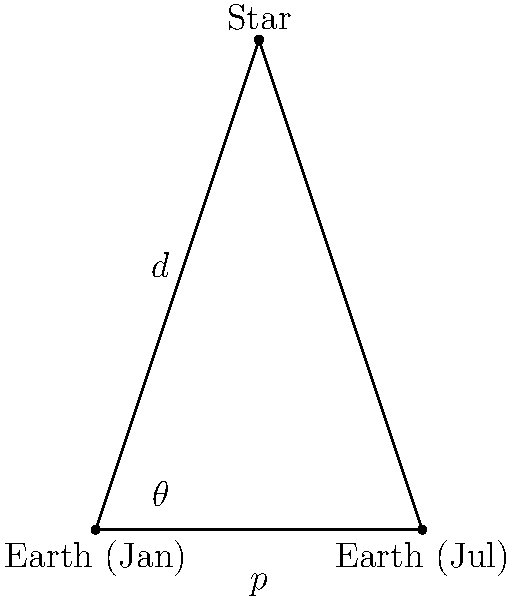As a 911 technology developer, you understand the importance of precise location data. In astronomy, determining the distance to stars is crucial. If a star has a parallax angle of 0.5 arcseconds when observed from Earth at opposite points in its orbit, what is the distance to this star in light-years? (Assume Earth's orbit radius is 1 AU) To calculate the distance to the star, we'll use the parallax method:

1) First, convert the parallax angle from arcseconds to radians:
   $\theta = 0.5 \text{ arcseconds} = 0.5 \times \frac{\pi}{180 \times 3600} \approx 2.4242 \times 10^{-6} \text{ radians}$

2) The distance $d$ to the star is given by the formula:
   $d = \frac{1 \text{ AU}}{\tan(\theta)}$

3) For small angles, $\tan(\theta) \approx \theta$ (in radians), so:
   $d \approx \frac{1 \text{ AU}}{2.4242 \times 10^{-6}} \approx 412,506 \text{ AU}$

4) Convert AU to light-years:
   1 light-year ≈ 63,241 AU
   $d \approx \frac{412,506}{63,241} \approx 6.52 \text{ light-years}$

Thus, the star is approximately 6.52 light-years away from Earth.
Answer: 6.52 light-years 